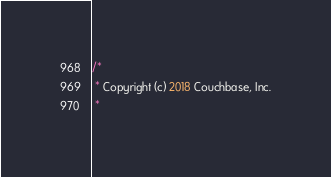Convert code to text. <code><loc_0><loc_0><loc_500><loc_500><_Java_>/*
 * Copyright (c) 2018 Couchbase, Inc.
 *</code> 